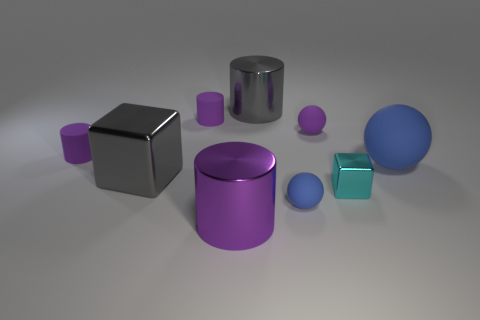How many purple cylinders must be subtracted to get 1 purple cylinders? 2 Subtract all green spheres. How many purple cylinders are left? 3 Add 1 big green balls. How many objects exist? 10 Subtract all cylinders. How many objects are left? 5 Subtract 0 green cubes. How many objects are left? 9 Subtract all blue metal spheres. Subtract all shiny cubes. How many objects are left? 7 Add 6 big gray cylinders. How many big gray cylinders are left? 7 Add 6 large purple rubber spheres. How many large purple rubber spheres exist? 6 